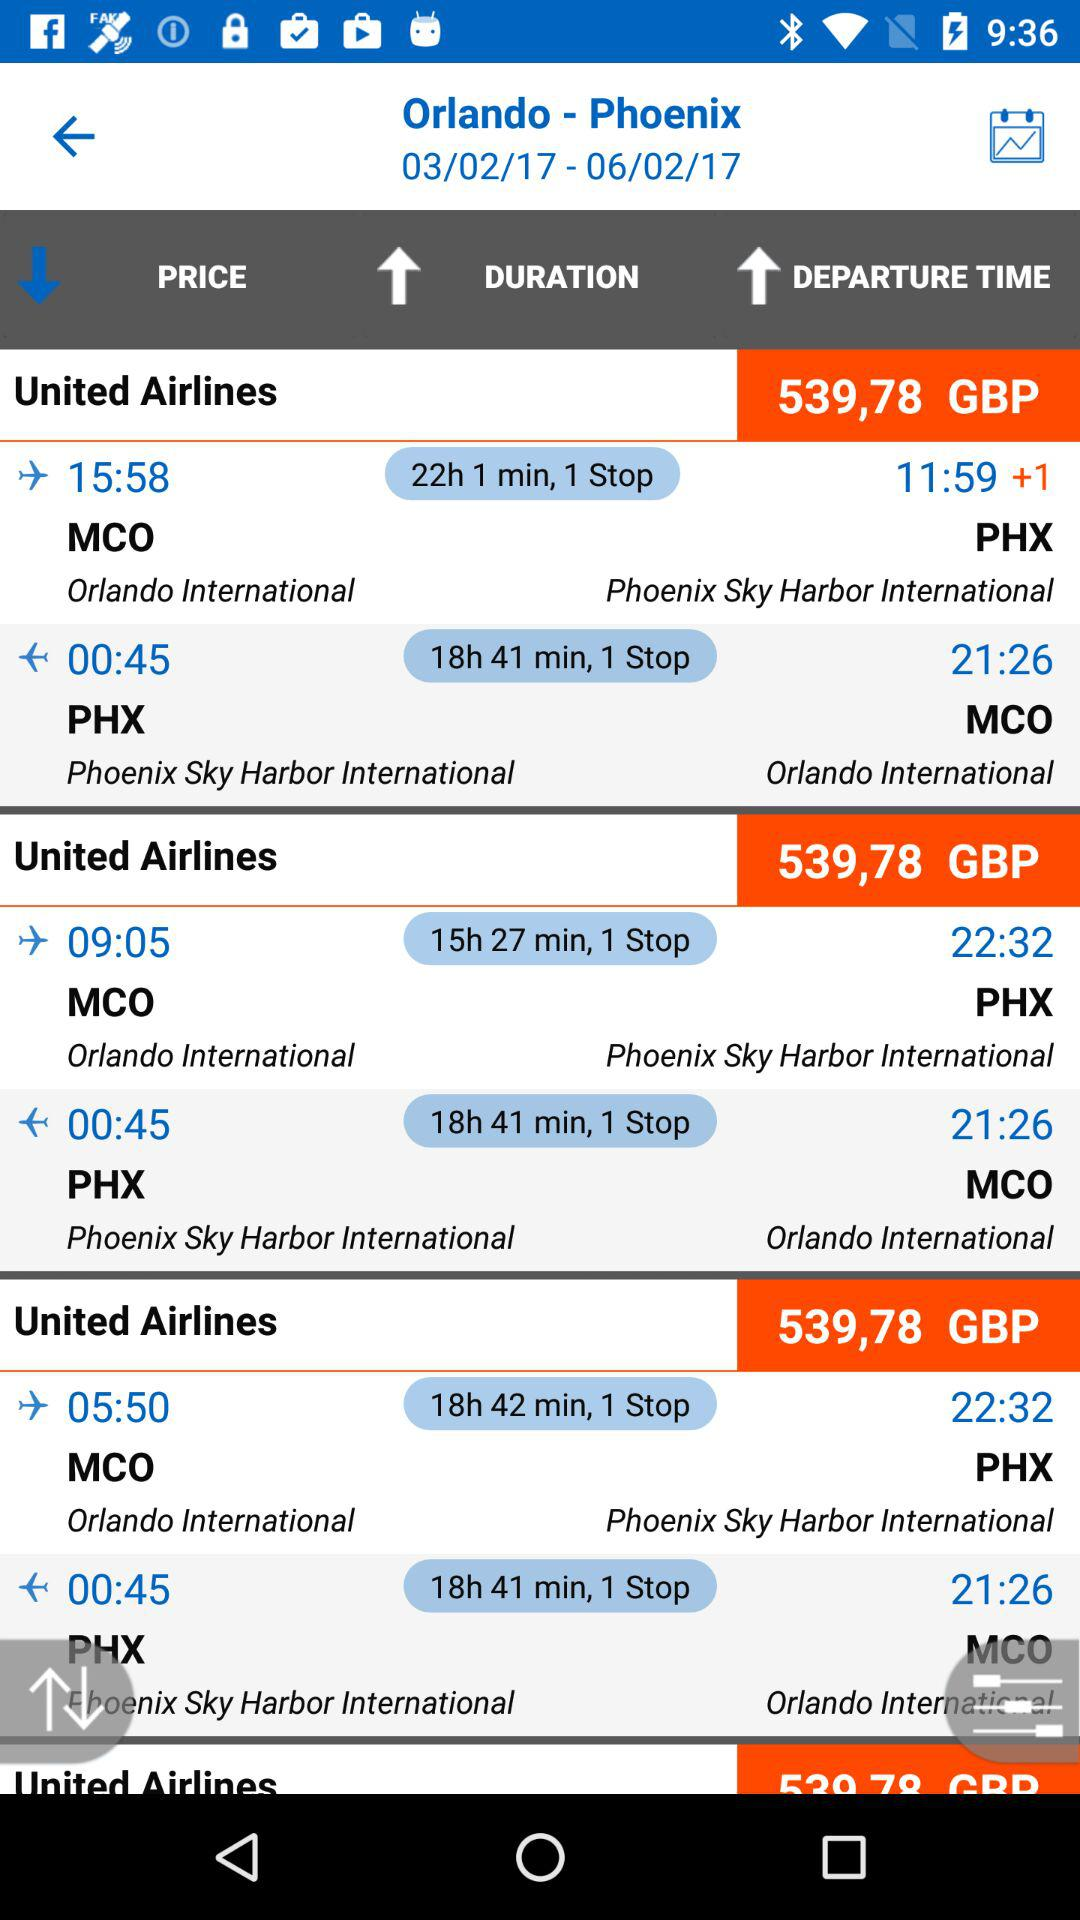What is the travel duration from PHX to MCO? The travel duration from PHX to MCO is 18 hours 41 minutes. 